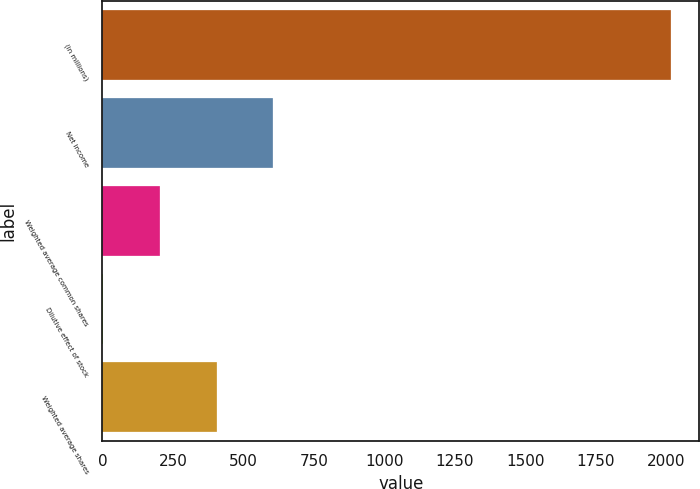<chart> <loc_0><loc_0><loc_500><loc_500><bar_chart><fcel>(in millions)<fcel>Net income<fcel>Weighted average common shares<fcel>Dilutive effect of stock<fcel>Weighted average shares<nl><fcel>2015<fcel>605.76<fcel>203.12<fcel>1.8<fcel>404.44<nl></chart> 